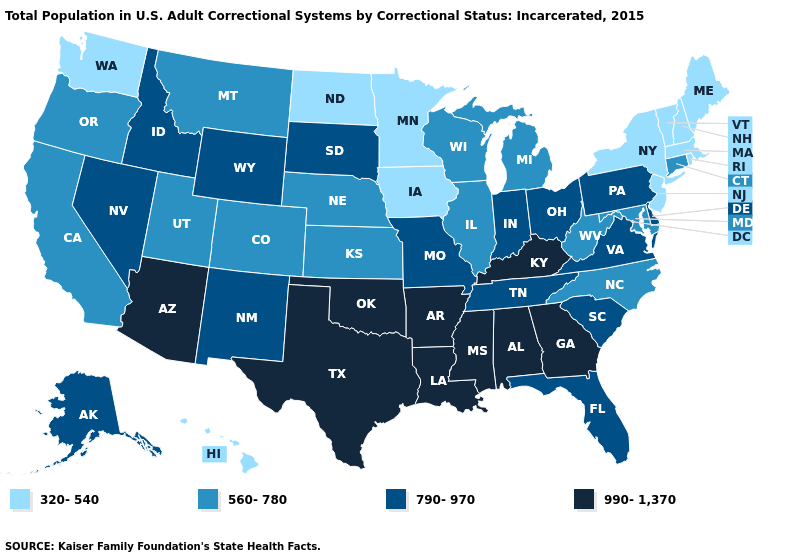What is the value of Mississippi?
Answer briefly. 990-1,370. What is the value of Mississippi?
Concise answer only. 990-1,370. Name the states that have a value in the range 560-780?
Quick response, please. California, Colorado, Connecticut, Illinois, Kansas, Maryland, Michigan, Montana, Nebraska, North Carolina, Oregon, Utah, West Virginia, Wisconsin. Name the states that have a value in the range 990-1,370?
Be succinct. Alabama, Arizona, Arkansas, Georgia, Kentucky, Louisiana, Mississippi, Oklahoma, Texas. Among the states that border Wyoming , does South Dakota have the highest value?
Keep it brief. Yes. Does Wisconsin have a higher value than West Virginia?
Concise answer only. No. What is the highest value in the USA?
Give a very brief answer. 990-1,370. Which states have the highest value in the USA?
Write a very short answer. Alabama, Arizona, Arkansas, Georgia, Kentucky, Louisiana, Mississippi, Oklahoma, Texas. What is the value of Rhode Island?
Concise answer only. 320-540. Does Vermont have the lowest value in the USA?
Short answer required. Yes. Name the states that have a value in the range 790-970?
Be succinct. Alaska, Delaware, Florida, Idaho, Indiana, Missouri, Nevada, New Mexico, Ohio, Pennsylvania, South Carolina, South Dakota, Tennessee, Virginia, Wyoming. Among the states that border Kansas , which have the lowest value?
Short answer required. Colorado, Nebraska. Does Massachusetts have the lowest value in the USA?
Be succinct. Yes. What is the highest value in the USA?
Give a very brief answer. 990-1,370. Does the first symbol in the legend represent the smallest category?
Answer briefly. Yes. 